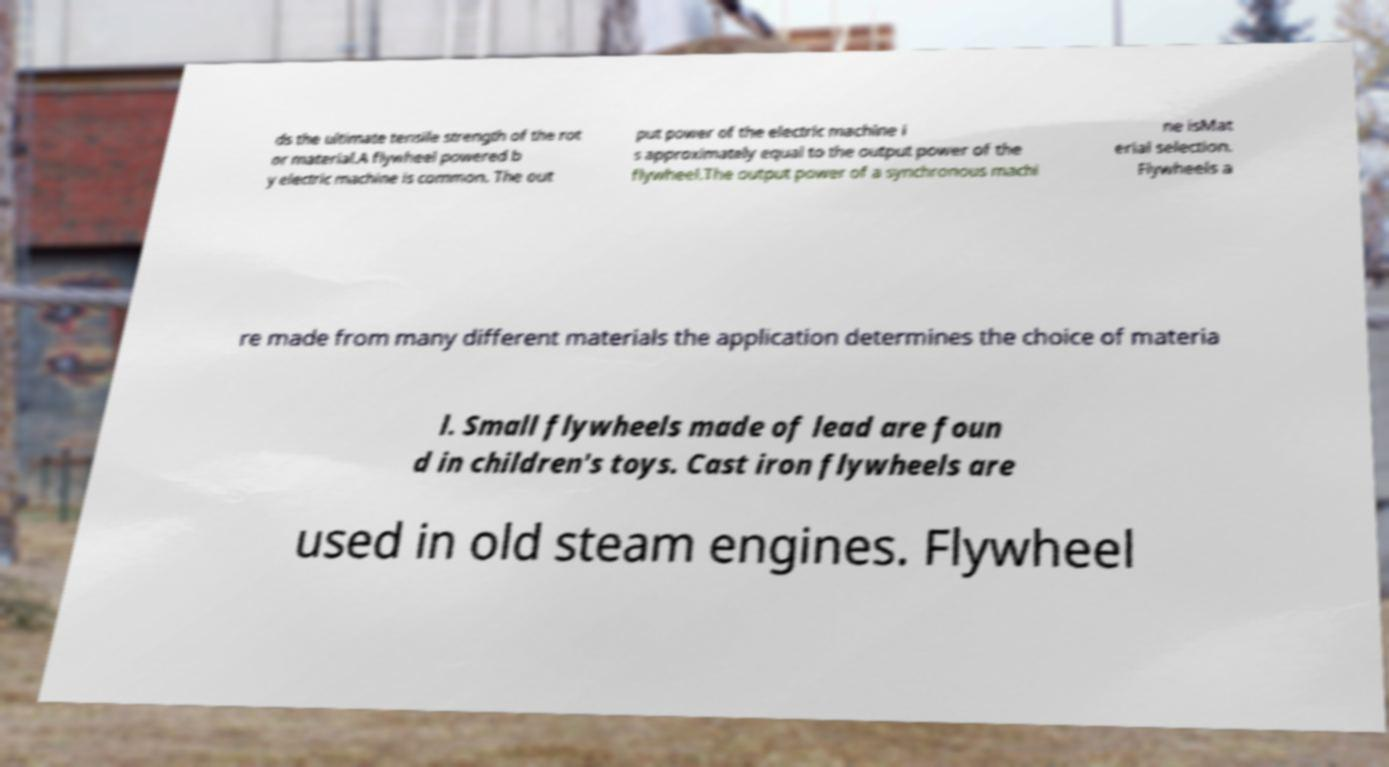For documentation purposes, I need the text within this image transcribed. Could you provide that? ds the ultimate tensile strength of the rot or material.A flywheel powered b y electric machine is common. The out put power of the electric machine i s approximately equal to the output power of the flywheel.The output power of a synchronous machi ne isMat erial selection. Flywheels a re made from many different materials the application determines the choice of materia l. Small flywheels made of lead are foun d in children's toys. Cast iron flywheels are used in old steam engines. Flywheel 